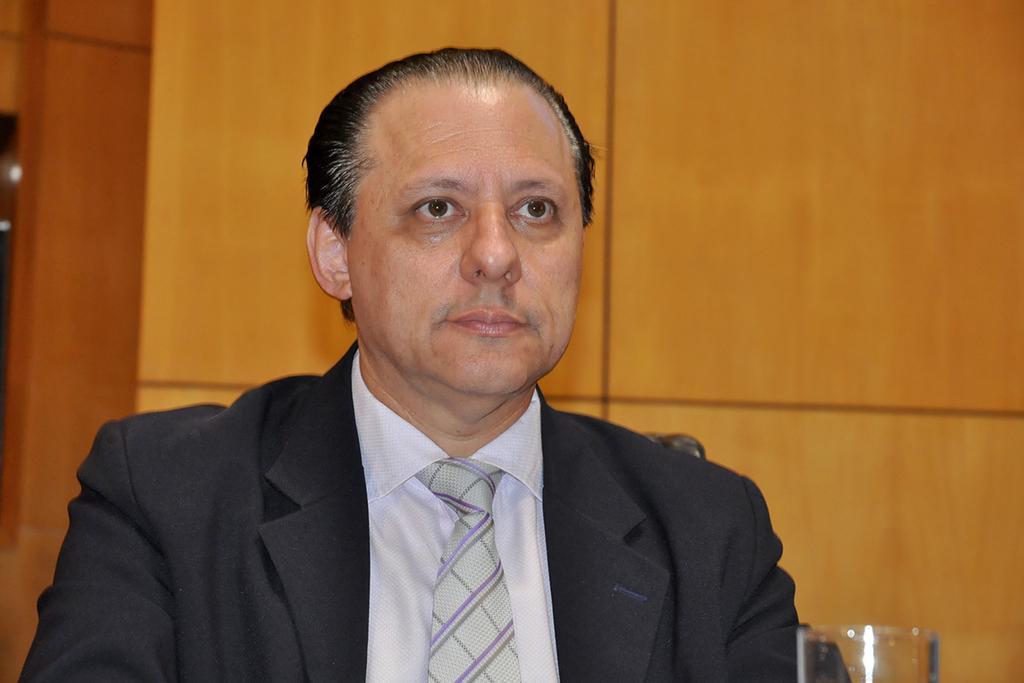Could you give a brief overview of what you see in this image? In the picture there is a man,he is wearing a blazer,shirt and a tie and there is a glass in front of the man,there is a wooden wall behind the man. 